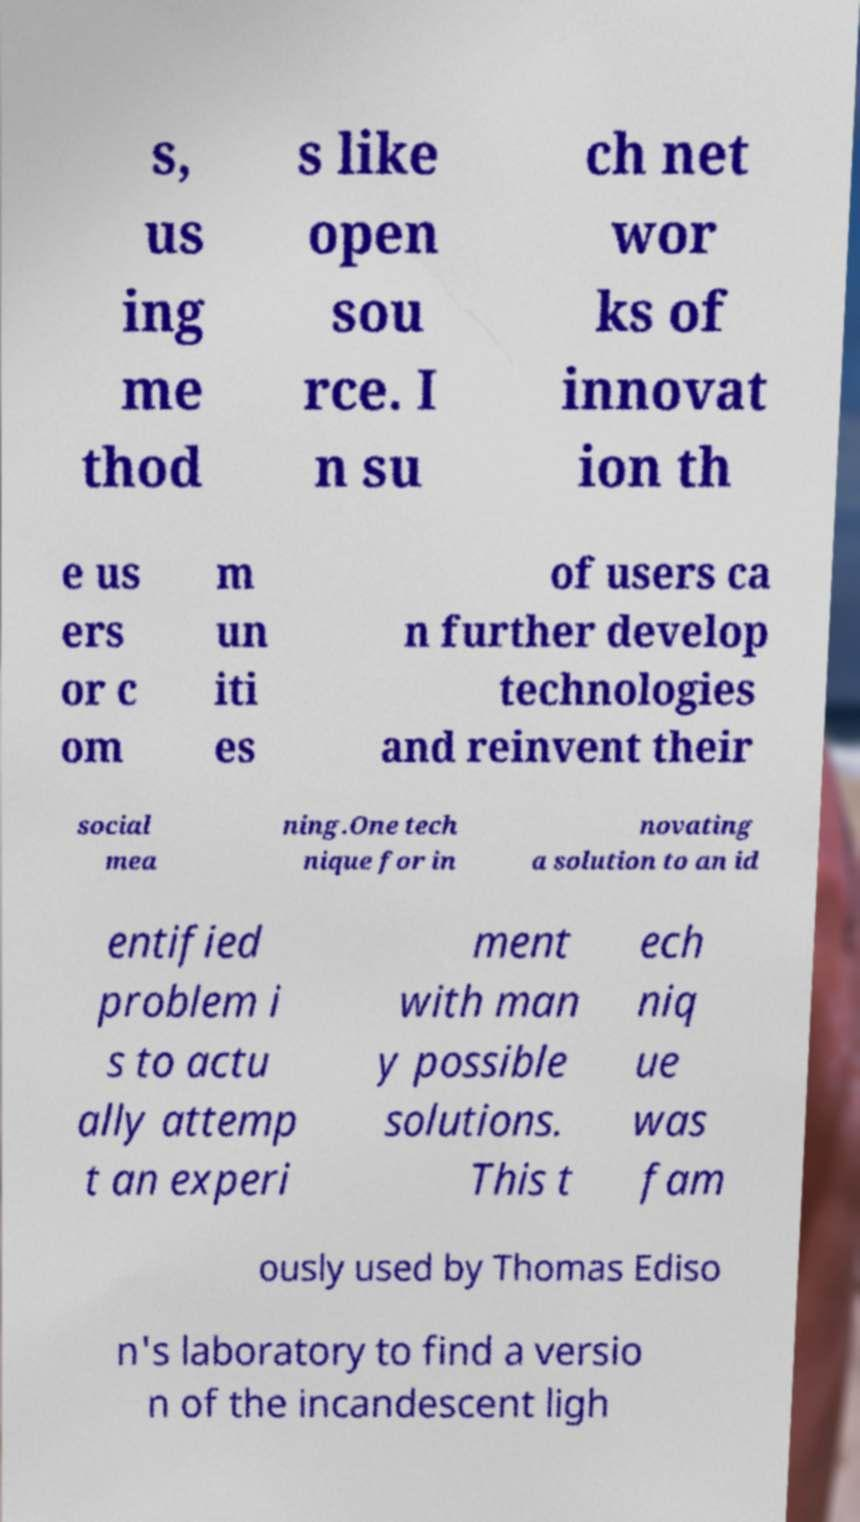Could you assist in decoding the text presented in this image and type it out clearly? s, us ing me thod s like open sou rce. I n su ch net wor ks of innovat ion th e us ers or c om m un iti es of users ca n further develop technologies and reinvent their social mea ning.One tech nique for in novating a solution to an id entified problem i s to actu ally attemp t an experi ment with man y possible solutions. This t ech niq ue was fam ously used by Thomas Ediso n's laboratory to find a versio n of the incandescent ligh 